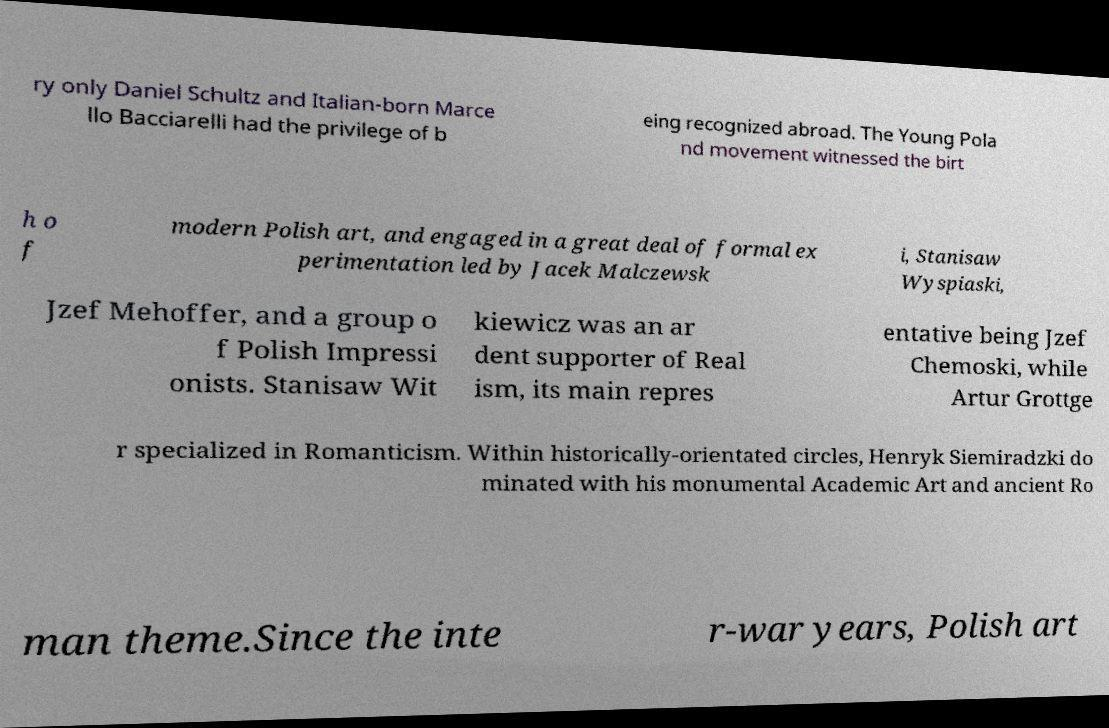Could you assist in decoding the text presented in this image and type it out clearly? ry only Daniel Schultz and Italian-born Marce llo Bacciarelli had the privilege of b eing recognized abroad. The Young Pola nd movement witnessed the birt h o f modern Polish art, and engaged in a great deal of formal ex perimentation led by Jacek Malczewsk i, Stanisaw Wyspiaski, Jzef Mehoffer, and a group o f Polish Impressi onists. Stanisaw Wit kiewicz was an ar dent supporter of Real ism, its main repres entative being Jzef Chemoski, while Artur Grottge r specialized in Romanticism. Within historically-orientated circles, Henryk Siemiradzki do minated with his monumental Academic Art and ancient Ro man theme.Since the inte r-war years, Polish art 